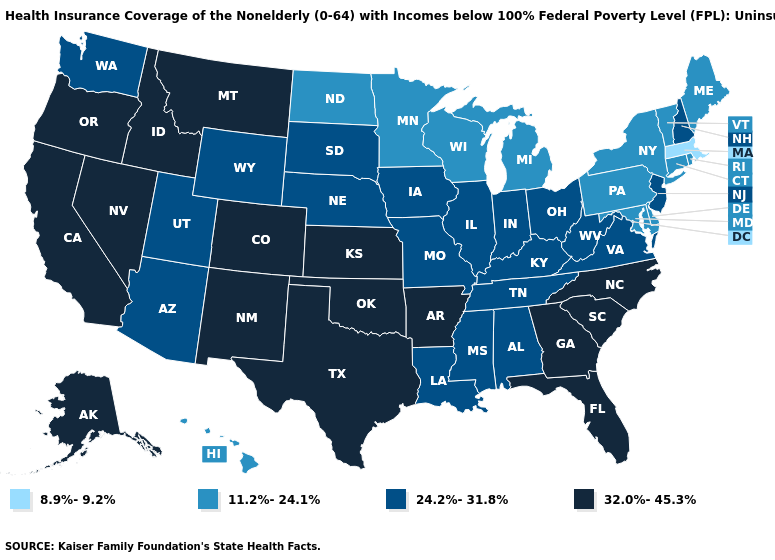Which states hav the highest value in the Northeast?
Concise answer only. New Hampshire, New Jersey. Name the states that have a value in the range 32.0%-45.3%?
Short answer required. Alaska, Arkansas, California, Colorado, Florida, Georgia, Idaho, Kansas, Montana, Nevada, New Mexico, North Carolina, Oklahoma, Oregon, South Carolina, Texas. Among the states that border Kentucky , which have the highest value?
Short answer required. Illinois, Indiana, Missouri, Ohio, Tennessee, Virginia, West Virginia. Among the states that border New Jersey , which have the highest value?
Quick response, please. Delaware, New York, Pennsylvania. Name the states that have a value in the range 8.9%-9.2%?
Short answer required. Massachusetts. Which states have the lowest value in the USA?
Short answer required. Massachusetts. Which states have the lowest value in the South?
Answer briefly. Delaware, Maryland. Is the legend a continuous bar?
Short answer required. No. Name the states that have a value in the range 11.2%-24.1%?
Concise answer only. Connecticut, Delaware, Hawaii, Maine, Maryland, Michigan, Minnesota, New York, North Dakota, Pennsylvania, Rhode Island, Vermont, Wisconsin. Does Massachusetts have the lowest value in the USA?
Keep it brief. Yes. Does Montana have the lowest value in the USA?
Short answer required. No. Among the states that border Colorado , which have the lowest value?
Give a very brief answer. Arizona, Nebraska, Utah, Wyoming. Among the states that border New Mexico , which have the highest value?
Write a very short answer. Colorado, Oklahoma, Texas. Name the states that have a value in the range 11.2%-24.1%?
Concise answer only. Connecticut, Delaware, Hawaii, Maine, Maryland, Michigan, Minnesota, New York, North Dakota, Pennsylvania, Rhode Island, Vermont, Wisconsin. What is the lowest value in the South?
Keep it brief. 11.2%-24.1%. 